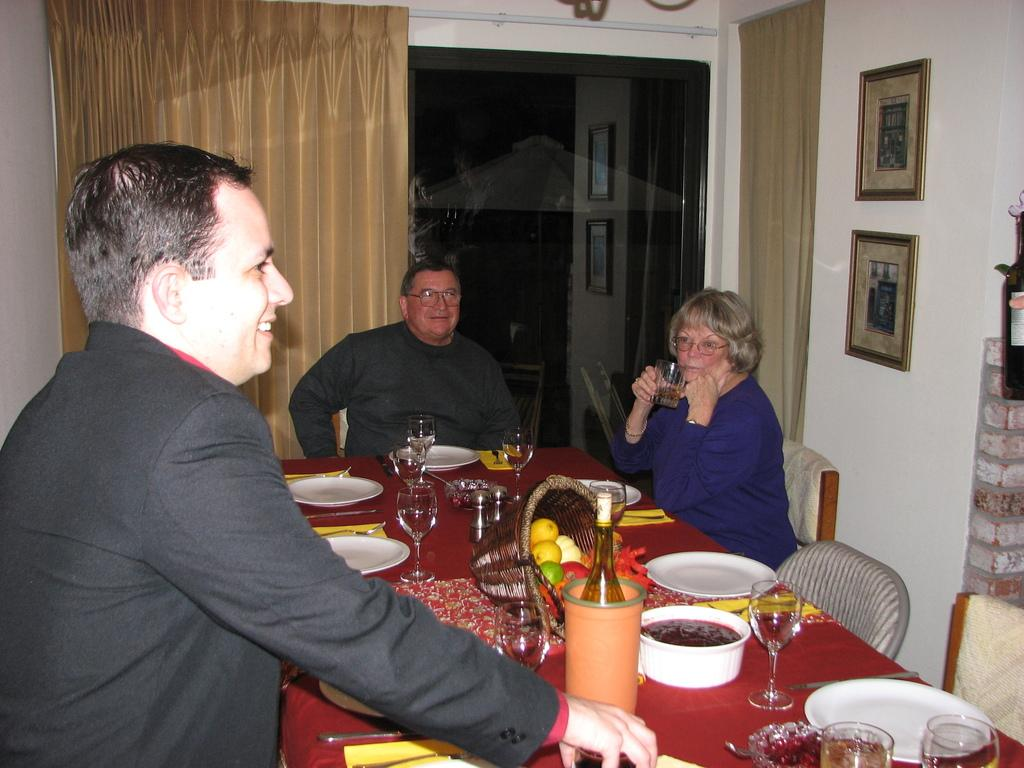Who is present in the image? There is a man and a woman in the image. What are the man and woman doing in the image? The man and woman are sitting around a table. What can be seen on the table in the image? Food is served on the table. What type of vest is the man wearing in the image? There is no mention of a vest in the image, so it cannot be determined if the man is wearing one. 